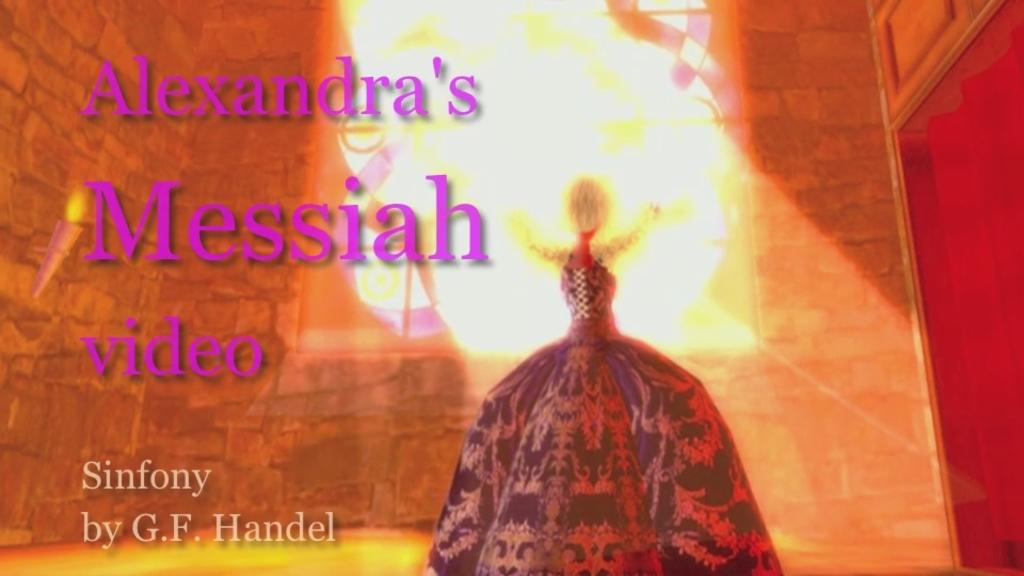<image>
Summarize the visual content of the image. A video that is titled Alexandra's Messiah Sinfony by G.F. Handel. 